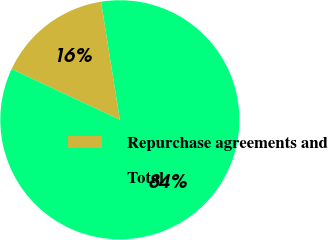<chart> <loc_0><loc_0><loc_500><loc_500><pie_chart><fcel>Repurchase agreements and<fcel>Total<nl><fcel>15.51%<fcel>84.49%<nl></chart> 